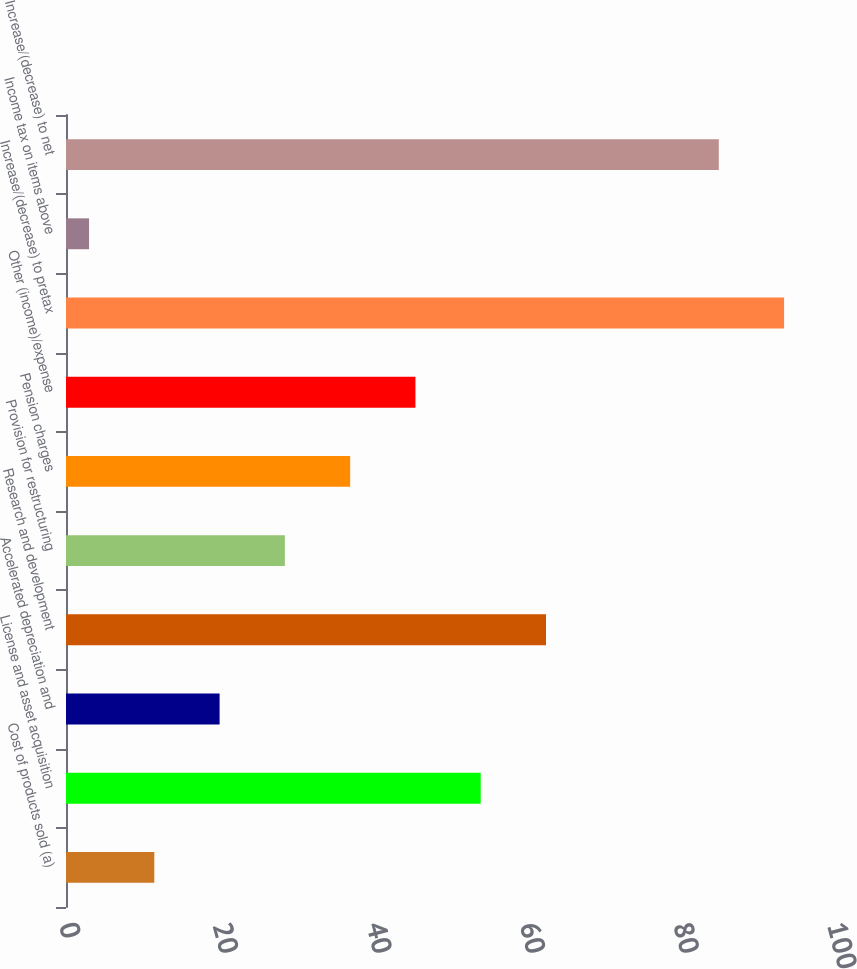Convert chart. <chart><loc_0><loc_0><loc_500><loc_500><bar_chart><fcel>Cost of products sold (a)<fcel>License and asset acquisition<fcel>Accelerated depreciation and<fcel>Research and development<fcel>Provision for restructuring<fcel>Pension charges<fcel>Other (income)/expense<fcel>Increase/(decrease) to pretax<fcel>Income tax on items above<fcel>Increase/(decrease) to net<nl><fcel>11.5<fcel>54<fcel>20<fcel>62.5<fcel>28.5<fcel>37<fcel>45.5<fcel>93.5<fcel>3<fcel>85<nl></chart> 